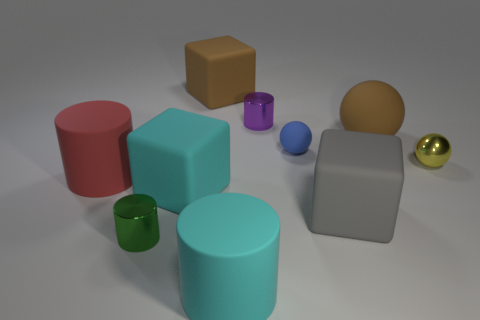There is a large sphere; is it the same color as the rubber block behind the tiny blue object?
Provide a short and direct response. Yes. Are there an equal number of cyan blocks that are left of the green cylinder and small metallic objects?
Your answer should be compact. No. How many brown rubber things have the same size as the blue thing?
Offer a terse response. 0. What is the shape of the object that is the same color as the large ball?
Your answer should be very brief. Cube. Is there a tiny red cylinder?
Your response must be concise. No. There is a tiny thing that is in front of the cyan cube; is it the same shape as the small thing on the right side of the blue matte thing?
Offer a terse response. No. What number of tiny objects are balls or purple metallic things?
Provide a succinct answer. 3. There is a red object that is made of the same material as the blue ball; what is its shape?
Provide a short and direct response. Cylinder. Is the shape of the small yellow metallic object the same as the tiny blue matte thing?
Provide a short and direct response. Yes. What color is the big sphere?
Make the answer very short. Brown. 